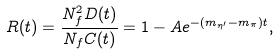<formula> <loc_0><loc_0><loc_500><loc_500>R ( t ) = \frac { N _ { f } ^ { 2 } D ( t ) } { N _ { f } C ( t ) } = 1 - A e ^ { - ( m _ { \eta ^ { \prime } } - m _ { \pi } ) t } ,</formula> 